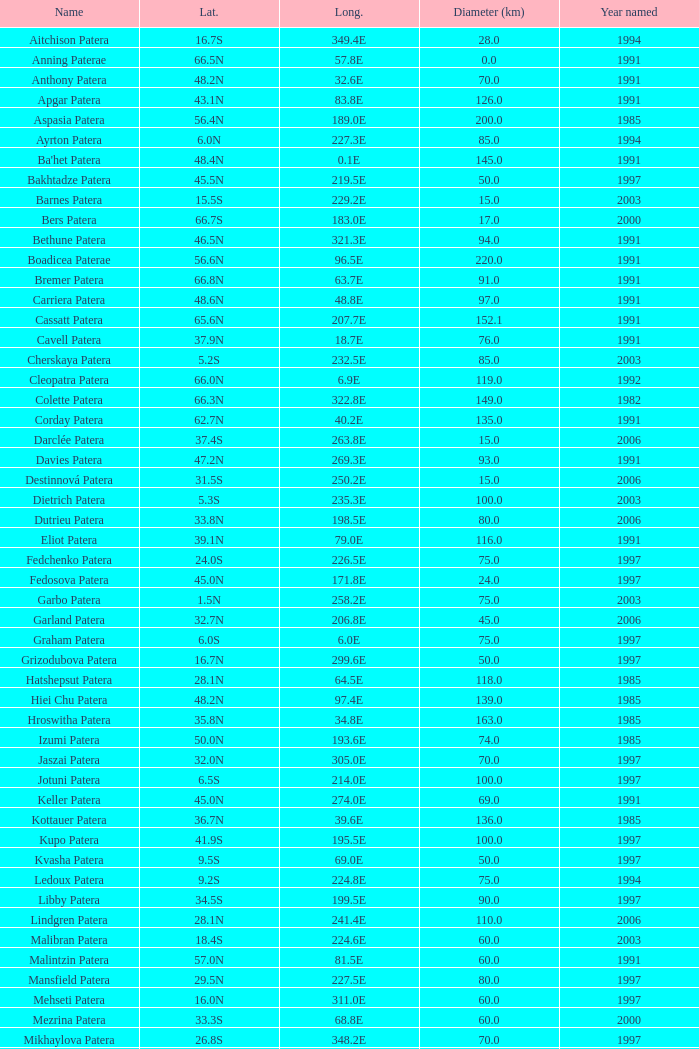What is the average Year Named, when Latitude is 37.9N, and when Diameter (km) is greater than 76? None. 